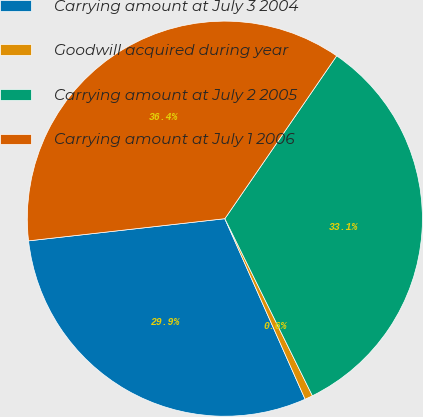Convert chart to OTSL. <chart><loc_0><loc_0><loc_500><loc_500><pie_chart><fcel>Carrying amount at July 3 2004<fcel>Goodwill acquired during year<fcel>Carrying amount at July 2 2005<fcel>Carrying amount at July 1 2006<nl><fcel>29.87%<fcel>0.65%<fcel>33.12%<fcel>36.37%<nl></chart> 